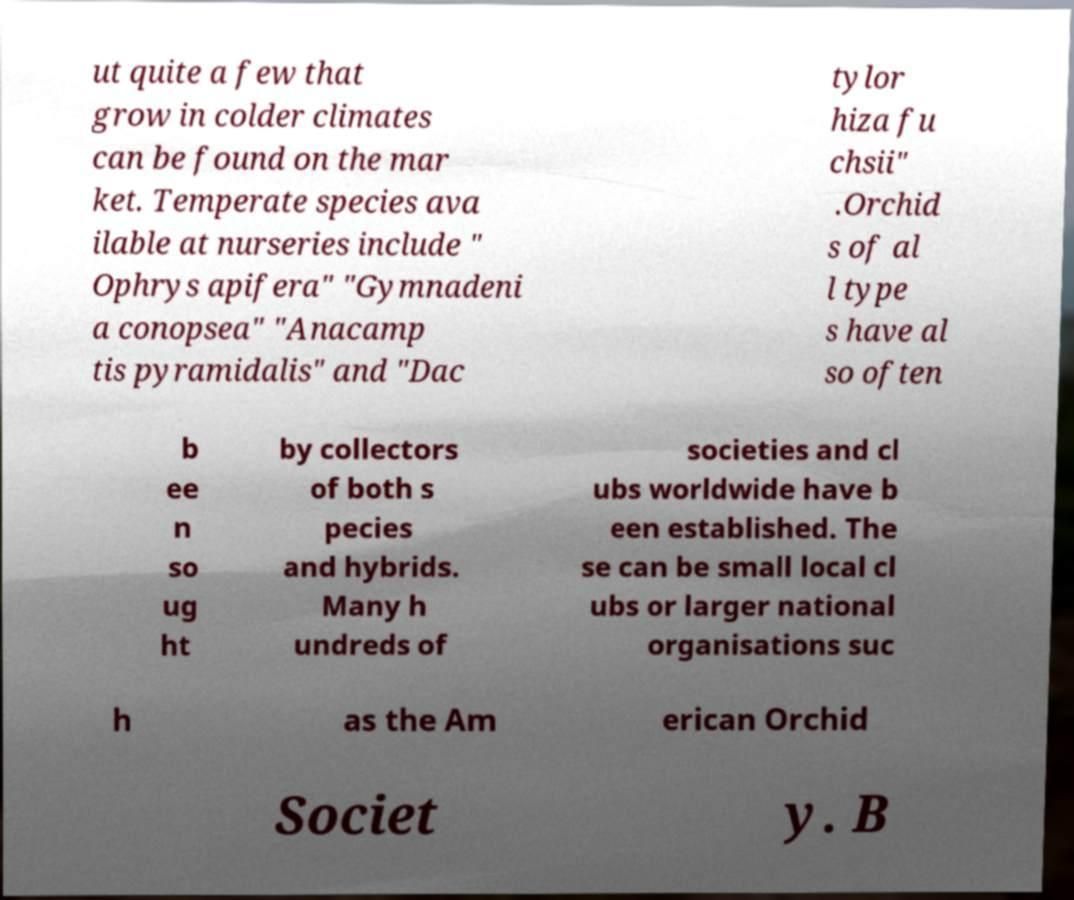Can you read and provide the text displayed in the image?This photo seems to have some interesting text. Can you extract and type it out for me? ut quite a few that grow in colder climates can be found on the mar ket. Temperate species ava ilable at nurseries include " Ophrys apifera" "Gymnadeni a conopsea" "Anacamp tis pyramidalis" and "Dac tylor hiza fu chsii" .Orchid s of al l type s have al so often b ee n so ug ht by collectors of both s pecies and hybrids. Many h undreds of societies and cl ubs worldwide have b een established. The se can be small local cl ubs or larger national organisations suc h as the Am erican Orchid Societ y. B 